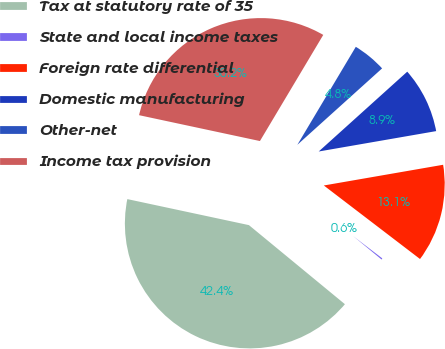<chart> <loc_0><loc_0><loc_500><loc_500><pie_chart><fcel>Tax at statutory rate of 35<fcel>State and local income taxes<fcel>Foreign rate differential<fcel>Domestic manufacturing<fcel>Other-net<fcel>Income tax provision<nl><fcel>42.38%<fcel>0.58%<fcel>13.12%<fcel>8.94%<fcel>4.76%<fcel>30.2%<nl></chart> 